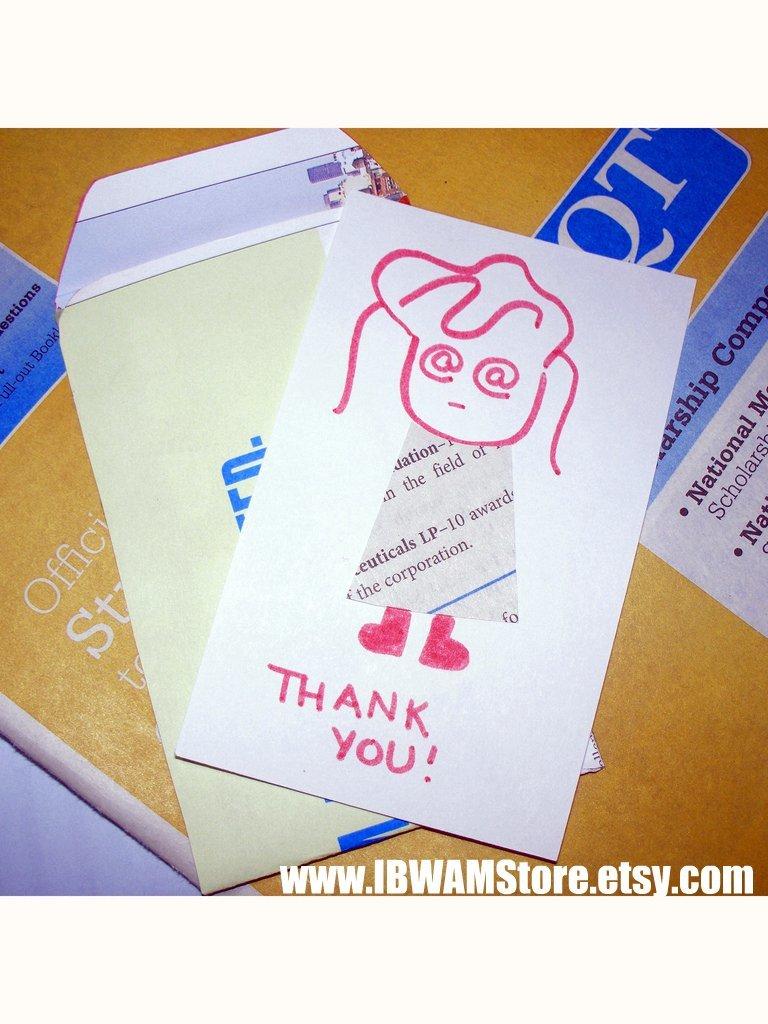What is written on the card?
Ensure brevity in your answer.  Thank you!. 